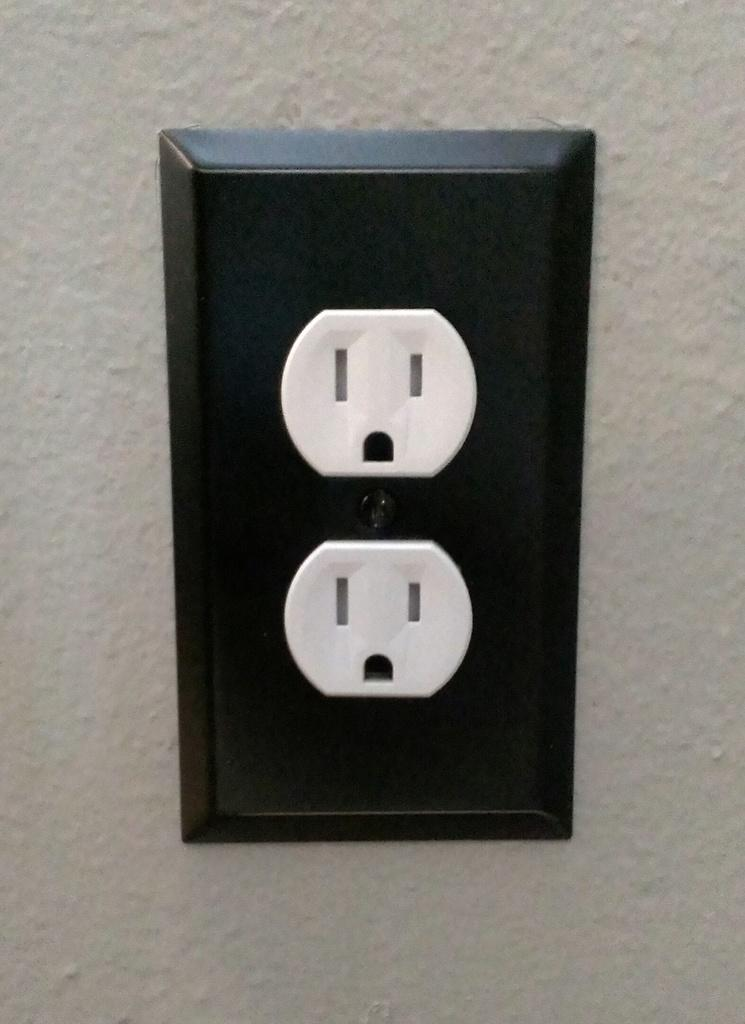What is located on the wall in the image? There is a switchboard on the wall in the image. Can you tell me how many cannons are visible in the image? There are no cannons present in the image; it features a switchboard on the wall. Is there anyone driving a car in the image? There is no car or person driving in the image; it only shows a switchboard on the wall. 